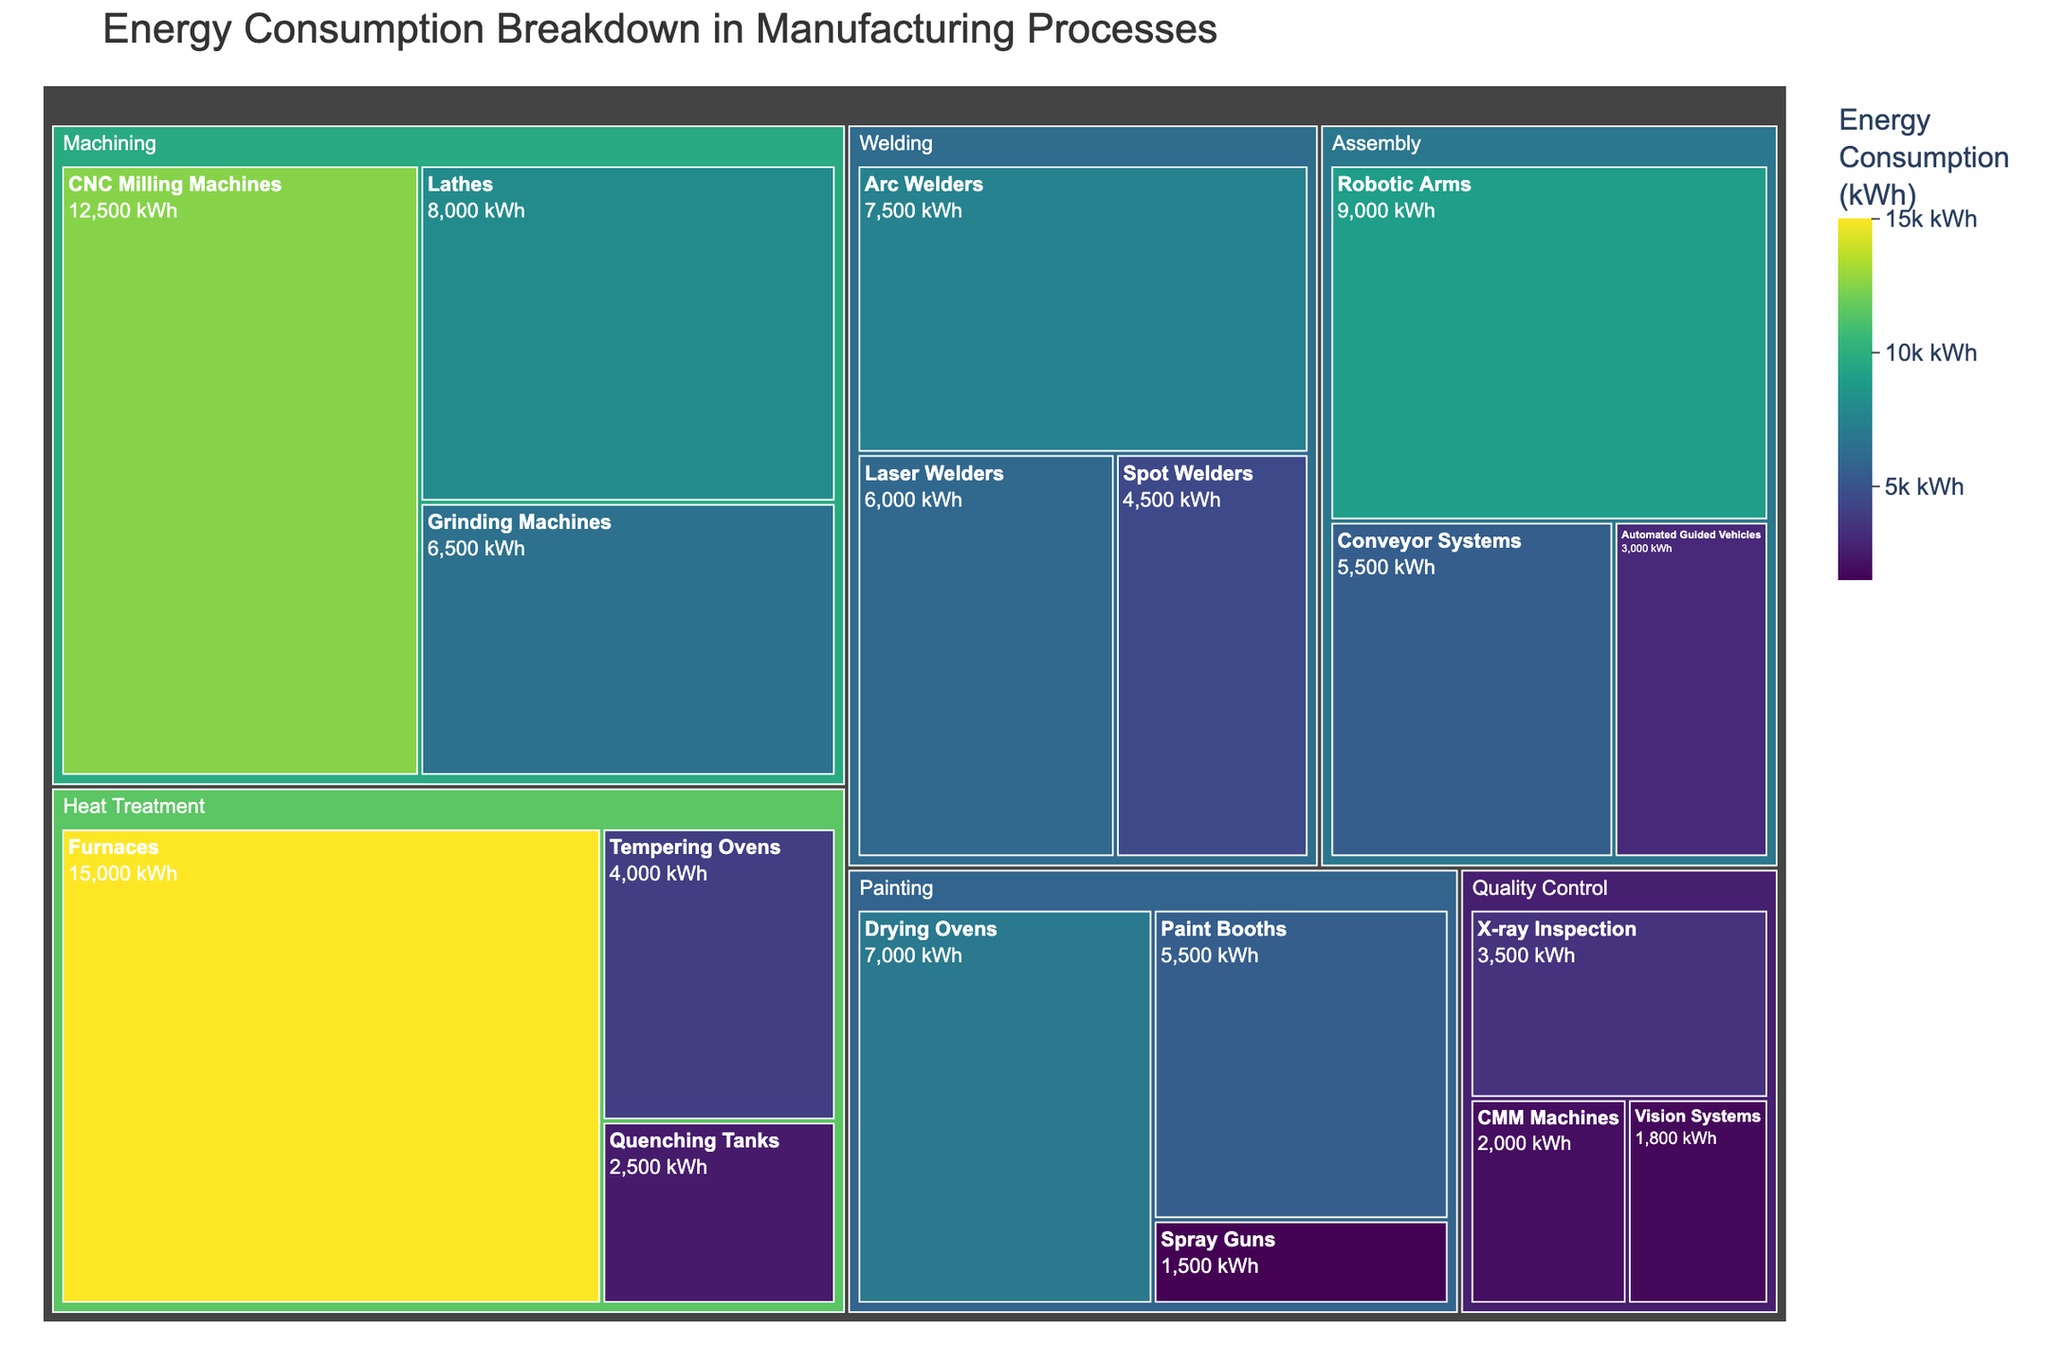What is the title of the treemap? The text at the top of the treemap corresponds to the title. It reads "Energy Consumption Breakdown in Manufacturing Processes".
Answer: Energy Consumption Breakdown in Manufacturing Processes Which equipment type in the Machining category consumes the most energy? In the Machining category, the equipment types are CNC Milling Machines, Lathes, and Grinding Machines, with their respective energy consumption shown in different sections. The largest section belongs to CNC Milling Machines.
Answer: CNC Milling Machines What is the total energy consumption for the Welding category? To find the total energy consumption for the Welding category, add the values for Arc Welders (7500 kWh), Spot Welders (4500 kWh), and Laser Welders (6000 kWh). So, 7500 + 4500 + 6000 = 18000 kWh.
Answer: 18000 kWh Compare the energy consumption of the Paint Booths and Drying Ovens in the Painting category. Which consumes more energy, and by how much? Paint Booths consume 5500 kWh and Drying Ovens consume 7000 kWh. To find the difference, subtract the consumption of Paint Booths from Drying Ovens: 7000 - 5500 = 1500 kWh.
Answer: Drying Ovens, 1500 kWh more What is the smallest energy consumption value shown in the treemap, and which equipment does it correspond to? The smallest energy consumption value on the treemap is visible with the smallest section. It is for Spray Guns in the Painting category which is 1500 kWh.
Answer: Spray Guns, 1500 kWh Among the equipment in the Assembly category, which one consumes the least energy? The Assembly category contains Robotic Arms (9000 kWh), Conveyor Systems (5500 kWh), and Automated Guided Vehicles (3000 kWh). The least consumption is by Automated Guided Vehicles.
Answer: Automated Guided Vehicles What is the average energy consumption of equipment in the Heat Treatment category? The Heat Treatment category includes Furnaces, Quenching Tanks, and Tempering Ovens with energy consumptions of 15000 kWh, 2500 kWh, and 4000 kWh respectively. The average is (15000 + 2500 + 4000) / 3 = 21500 / 3 = 7167 kWh (approximately).
Answer: 7167 kWh How does the energy consumption of the entire Painting category compare to that of the Machining category? Add the consumption values for Painting: Paint Booths (5500 kWh), Drying Ovens (7000 kWh), Spray Guns (1500 kWh) which totals to 5500 + 7000 + 1500 = 14000 kWh. For Machining: CNC Milling Machines (12500 kWh), Lathes (8000 kWh), Grinding Machines (6500 kWh) totals to 12500 + 8000 + 6500 = 27000 kWh. The Machining category consumes more energy.
Answer: Machining category consumes 13000 kWh more than Painting category What is the energy consumption difference between the highest and lowest consuming equipment? The highest consuming equipment is Furnaces with 15000 kWh, and the lowest is Spray Guns with 1500 kWh. The difference is 15000 - 1500 = 13500 kWh.
Answer: 13500 kWh How many equipment types have an energy consumption greater than 7000 kWh? Scan through the treemap, identifying sections with labels and values greater than 7000 kWh: CNC Milling Machines, Lathes, Robotic Arms, Arc Welders, Drying Ovens, and Furnaces. This gives a total of 6 equipment types.
Answer: 6 